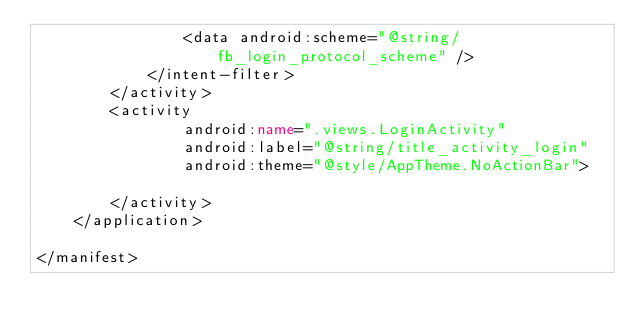<code> <loc_0><loc_0><loc_500><loc_500><_XML_>                <data android:scheme="@string/fb_login_protocol_scheme" />
            </intent-filter>
        </activity>
        <activity
                android:name=".views.LoginActivity"
                android:label="@string/title_activity_login"
                android:theme="@style/AppTheme.NoActionBar">

        </activity>
    </application>

</manifest></code> 